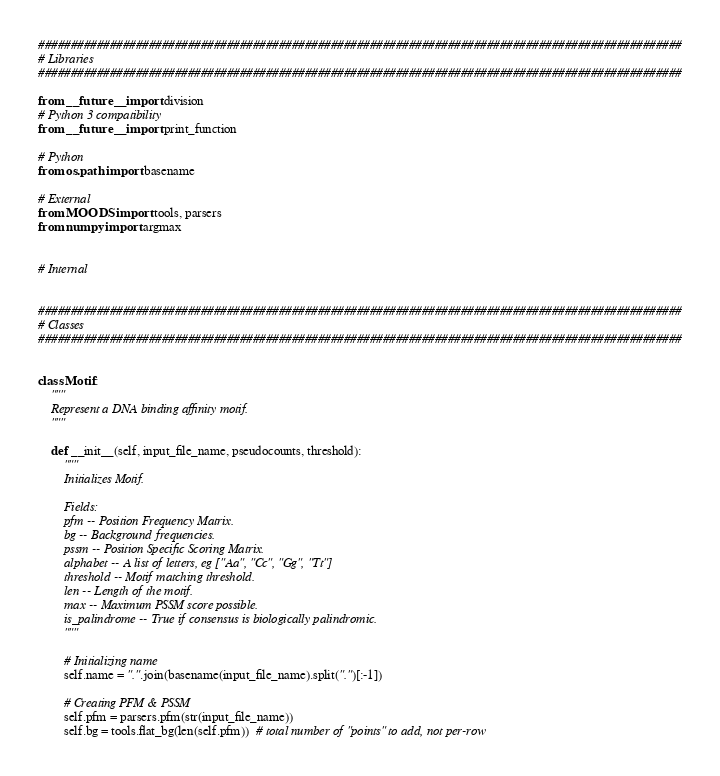<code> <loc_0><loc_0><loc_500><loc_500><_Python_>###################################################################################################
# Libraries
###################################################################################################

from __future__ import division
# Python 3 compatibility
from __future__ import print_function

# Python
from os.path import basename

# External
from MOODS import tools, parsers
from numpy import argmax


# Internal


###################################################################################################
# Classes
###################################################################################################


class Motif:
    """
    Represent a DNA binding affinity motif.
    """

    def __init__(self, input_file_name, pseudocounts, threshold):
        """ 
        Initializes Motif.

        Fields:
        pfm -- Position Frequency Matrix.
        bg -- Background frequencies.
        pssm -- Position Specific Scoring Matrix.
        alphabet -- A list of letters, eg ["Aa", "Cc", "Gg", "Tt"]
        threshold -- Motif matching threshold.
        len -- Length of the motif.
        max -- Maximum PSSM score possible.
        is_palindrome -- True if consensus is biologically palindromic.
        """

        # Initializing name
        self.name = ".".join(basename(input_file_name).split(".")[:-1])

        # Creating PFM & PSSM
        self.pfm = parsers.pfm(str(input_file_name))
        self.bg = tools.flat_bg(len(self.pfm))  # total number of "points" to add, not per-row</code> 